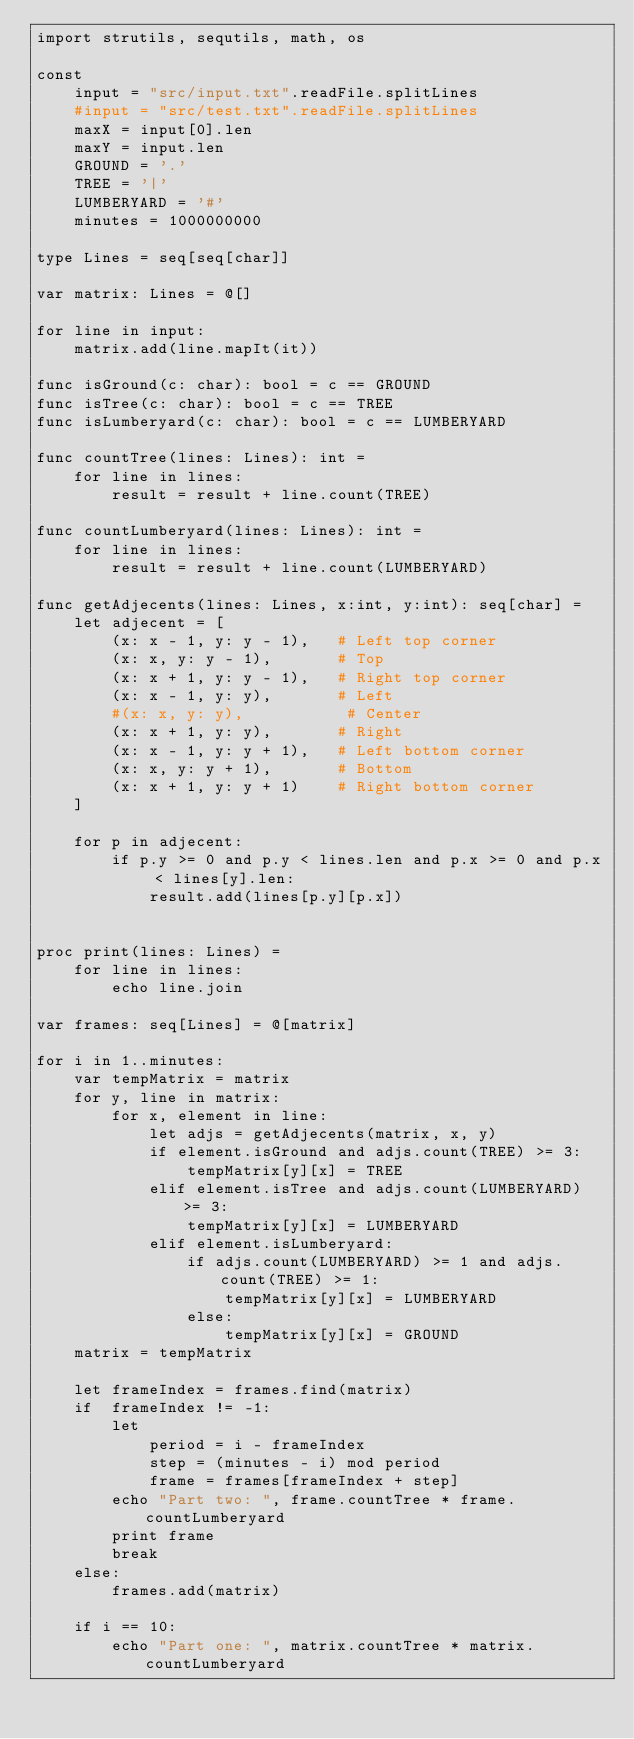Convert code to text. <code><loc_0><loc_0><loc_500><loc_500><_Nim_>import strutils, sequtils, math, os

const 
    input = "src/input.txt".readFile.splitLines
    #input = "src/test.txt".readFile.splitLines
    maxX = input[0].len
    maxY = input.len
    GROUND = '.'
    TREE = '|'
    LUMBERYARD = '#'
    minutes = 1000000000

type Lines = seq[seq[char]]

var matrix: Lines = @[]

for line in input:
    matrix.add(line.mapIt(it))

func isGround(c: char): bool = c == GROUND
func isTree(c: char): bool = c == TREE
func isLumberyard(c: char): bool = c == LUMBERYARD

func countTree(lines: Lines): int =
    for line in lines:
        result = result + line.count(TREE)

func countLumberyard(lines: Lines): int =
    for line in lines:
        result = result + line.count(LUMBERYARD)

func getAdjecents(lines: Lines, x:int, y:int): seq[char] =
    let adjecent = [
        (x: x - 1, y: y - 1),   # Left top corner
        (x: x, y: y - 1),       # Top
        (x: x + 1, y: y - 1),   # Right top corner
        (x: x - 1, y: y),       # Left
        #(x: x, y: y),           # Center
        (x: x + 1, y: y),       # Right
        (x: x - 1, y: y + 1),   # Left bottom corner
        (x: x, y: y + 1),       # Bottom
        (x: x + 1, y: y + 1)    # Right bottom corner
    ]

    for p in adjecent:
        if p.y >= 0 and p.y < lines.len and p.x >= 0 and p.x < lines[y].len:
            result.add(lines[p.y][p.x])


proc print(lines: Lines) = 
    for line in lines:
        echo line.join

var frames: seq[Lines] = @[matrix]

for i in 1..minutes:
    var tempMatrix = matrix
    for y, line in matrix:
        for x, element in line:
            let adjs = getAdjecents(matrix, x, y)
            if element.isGround and adjs.count(TREE) >= 3:
                tempMatrix[y][x] = TREE
            elif element.isTree and adjs.count(LUMBERYARD) >= 3:
                tempMatrix[y][x] = LUMBERYARD
            elif element.isLumberyard:
                if adjs.count(LUMBERYARD) >= 1 and adjs.count(TREE) >= 1:
                    tempMatrix[y][x] = LUMBERYARD
                else:
                    tempMatrix[y][x] = GROUND
    matrix = tempMatrix
    
    let frameIndex = frames.find(matrix)
    if  frameIndex != -1:
        let 
            period = i - frameIndex
            step = (minutes - i) mod period
            frame = frames[frameIndex + step]
        echo "Part two: ", frame.countTree * frame.countLumberyard
        print frame
        break
    else:
        frames.add(matrix)
    
    if i == 10:
        echo "Part one: ", matrix.countTree * matrix.countLumberyard
</code> 